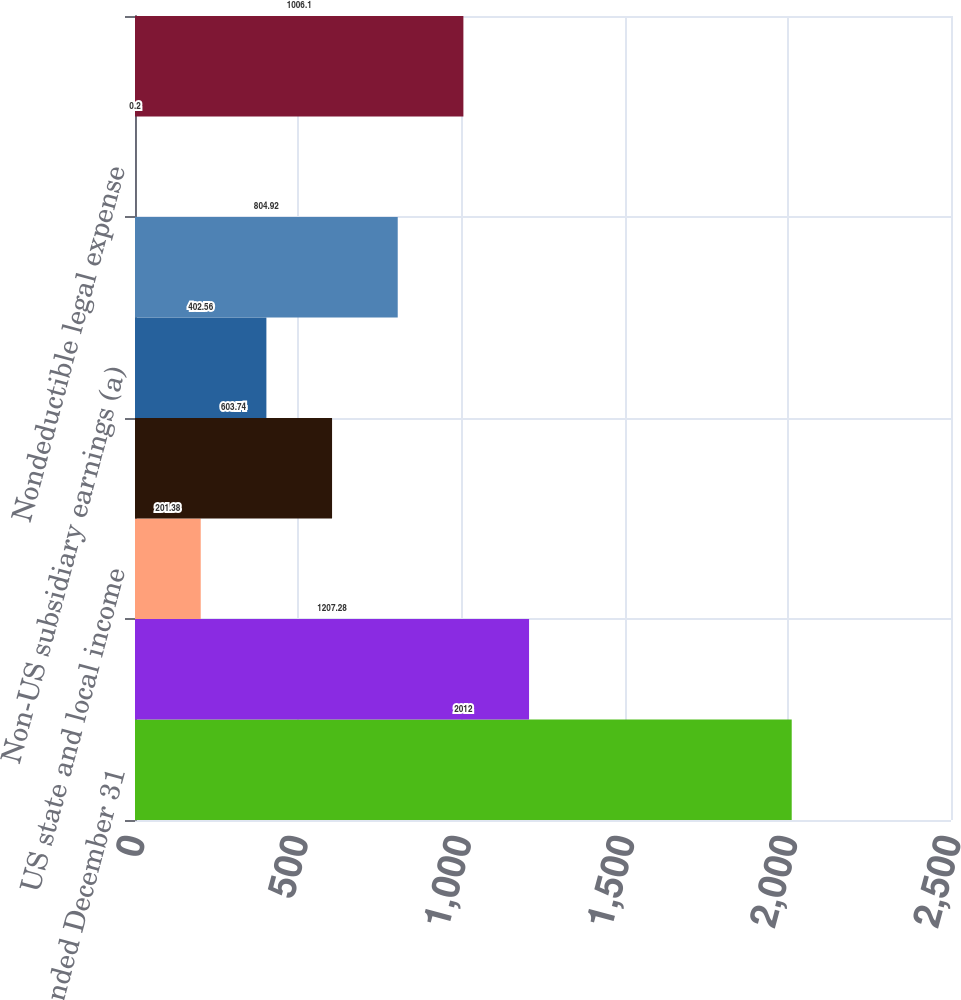Convert chart to OTSL. <chart><loc_0><loc_0><loc_500><loc_500><bar_chart><fcel>Year ended December 31<fcel>Statutory US federal tax rate<fcel>US state and local income<fcel>Tax-exempt income<fcel>Non-US subsidiary earnings (a)<fcel>Business tax credits<fcel>Nondeductible legal expense<fcel>Effective tax rate<nl><fcel>2012<fcel>1207.28<fcel>201.38<fcel>603.74<fcel>402.56<fcel>804.92<fcel>0.2<fcel>1006.1<nl></chart> 